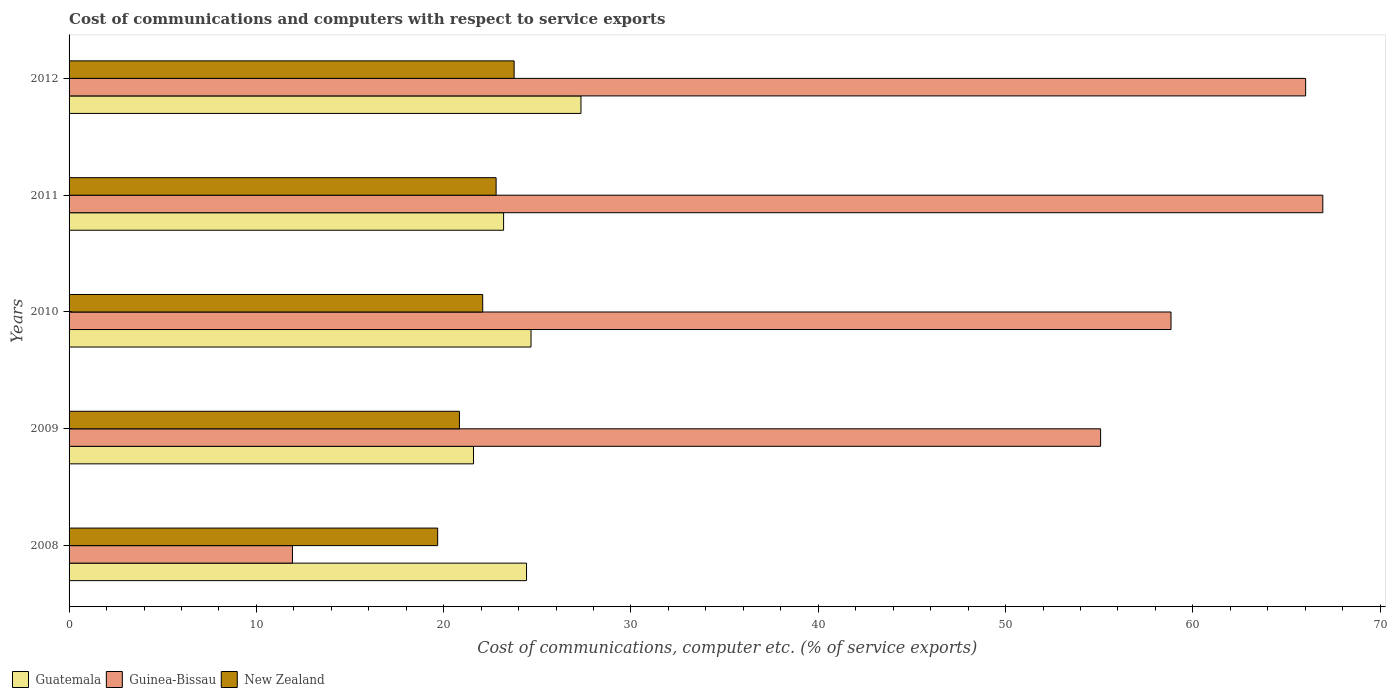Are the number of bars per tick equal to the number of legend labels?
Ensure brevity in your answer.  Yes. Are the number of bars on each tick of the Y-axis equal?
Provide a short and direct response. Yes. In how many cases, is the number of bars for a given year not equal to the number of legend labels?
Your answer should be compact. 0. What is the cost of communications and computers in Guatemala in 2008?
Make the answer very short. 24.42. Across all years, what is the maximum cost of communications and computers in Guatemala?
Your answer should be very brief. 27.33. Across all years, what is the minimum cost of communications and computers in Guatemala?
Offer a terse response. 21.59. In which year was the cost of communications and computers in Guatemala maximum?
Provide a short and direct response. 2012. In which year was the cost of communications and computers in New Zealand minimum?
Provide a short and direct response. 2008. What is the total cost of communications and computers in Guinea-Bissau in the graph?
Your answer should be very brief. 258.78. What is the difference between the cost of communications and computers in New Zealand in 2011 and that in 2012?
Your answer should be compact. -0.96. What is the difference between the cost of communications and computers in Guinea-Bissau in 2009 and the cost of communications and computers in Guatemala in 2008?
Your answer should be very brief. 30.65. What is the average cost of communications and computers in Guatemala per year?
Your answer should be compact. 24.24. In the year 2009, what is the difference between the cost of communications and computers in Guinea-Bissau and cost of communications and computers in New Zealand?
Your response must be concise. 34.23. What is the ratio of the cost of communications and computers in Guatemala in 2009 to that in 2011?
Provide a short and direct response. 0.93. Is the cost of communications and computers in New Zealand in 2009 less than that in 2010?
Your answer should be very brief. Yes. What is the difference between the highest and the second highest cost of communications and computers in Guinea-Bissau?
Your response must be concise. 0.92. What is the difference between the highest and the lowest cost of communications and computers in New Zealand?
Provide a succinct answer. 4.08. In how many years, is the cost of communications and computers in Guatemala greater than the average cost of communications and computers in Guatemala taken over all years?
Provide a succinct answer. 3. Is the sum of the cost of communications and computers in Guinea-Bissau in 2010 and 2012 greater than the maximum cost of communications and computers in New Zealand across all years?
Provide a short and direct response. Yes. What does the 1st bar from the top in 2010 represents?
Provide a succinct answer. New Zealand. What does the 1st bar from the bottom in 2010 represents?
Make the answer very short. Guatemala. How many bars are there?
Make the answer very short. 15. What is the difference between two consecutive major ticks on the X-axis?
Offer a very short reply. 10. What is the title of the graph?
Keep it short and to the point. Cost of communications and computers with respect to service exports. Does "Isle of Man" appear as one of the legend labels in the graph?
Ensure brevity in your answer.  No. What is the label or title of the X-axis?
Ensure brevity in your answer.  Cost of communications, computer etc. (% of service exports). What is the Cost of communications, computer etc. (% of service exports) in Guatemala in 2008?
Provide a succinct answer. 24.42. What is the Cost of communications, computer etc. (% of service exports) in Guinea-Bissau in 2008?
Your response must be concise. 11.93. What is the Cost of communications, computer etc. (% of service exports) of New Zealand in 2008?
Your answer should be very brief. 19.68. What is the Cost of communications, computer etc. (% of service exports) of Guatemala in 2009?
Ensure brevity in your answer.  21.59. What is the Cost of communications, computer etc. (% of service exports) in Guinea-Bissau in 2009?
Your answer should be very brief. 55.07. What is the Cost of communications, computer etc. (% of service exports) of New Zealand in 2009?
Your answer should be compact. 20.84. What is the Cost of communications, computer etc. (% of service exports) in Guatemala in 2010?
Offer a very short reply. 24.66. What is the Cost of communications, computer etc. (% of service exports) of Guinea-Bissau in 2010?
Keep it short and to the point. 58.83. What is the Cost of communications, computer etc. (% of service exports) of New Zealand in 2010?
Your response must be concise. 22.08. What is the Cost of communications, computer etc. (% of service exports) in Guatemala in 2011?
Offer a terse response. 23.2. What is the Cost of communications, computer etc. (% of service exports) of Guinea-Bissau in 2011?
Offer a terse response. 66.94. What is the Cost of communications, computer etc. (% of service exports) of New Zealand in 2011?
Give a very brief answer. 22.8. What is the Cost of communications, computer etc. (% of service exports) of Guatemala in 2012?
Keep it short and to the point. 27.33. What is the Cost of communications, computer etc. (% of service exports) of Guinea-Bissau in 2012?
Offer a very short reply. 66.02. What is the Cost of communications, computer etc. (% of service exports) of New Zealand in 2012?
Give a very brief answer. 23.76. Across all years, what is the maximum Cost of communications, computer etc. (% of service exports) in Guatemala?
Your response must be concise. 27.33. Across all years, what is the maximum Cost of communications, computer etc. (% of service exports) of Guinea-Bissau?
Your answer should be very brief. 66.94. Across all years, what is the maximum Cost of communications, computer etc. (% of service exports) in New Zealand?
Offer a very short reply. 23.76. Across all years, what is the minimum Cost of communications, computer etc. (% of service exports) of Guatemala?
Your answer should be compact. 21.59. Across all years, what is the minimum Cost of communications, computer etc. (% of service exports) in Guinea-Bissau?
Your response must be concise. 11.93. Across all years, what is the minimum Cost of communications, computer etc. (% of service exports) in New Zealand?
Your response must be concise. 19.68. What is the total Cost of communications, computer etc. (% of service exports) in Guatemala in the graph?
Your answer should be very brief. 121.21. What is the total Cost of communications, computer etc. (% of service exports) in Guinea-Bissau in the graph?
Your answer should be very brief. 258.78. What is the total Cost of communications, computer etc. (% of service exports) in New Zealand in the graph?
Give a very brief answer. 109.16. What is the difference between the Cost of communications, computer etc. (% of service exports) of Guatemala in 2008 and that in 2009?
Offer a very short reply. 2.83. What is the difference between the Cost of communications, computer etc. (% of service exports) of Guinea-Bissau in 2008 and that in 2009?
Provide a short and direct response. -43.15. What is the difference between the Cost of communications, computer etc. (% of service exports) of New Zealand in 2008 and that in 2009?
Your answer should be compact. -1.16. What is the difference between the Cost of communications, computer etc. (% of service exports) in Guatemala in 2008 and that in 2010?
Provide a short and direct response. -0.24. What is the difference between the Cost of communications, computer etc. (% of service exports) in Guinea-Bissau in 2008 and that in 2010?
Your response must be concise. -46.91. What is the difference between the Cost of communications, computer etc. (% of service exports) in New Zealand in 2008 and that in 2010?
Your answer should be compact. -2.4. What is the difference between the Cost of communications, computer etc. (% of service exports) of Guatemala in 2008 and that in 2011?
Keep it short and to the point. 1.22. What is the difference between the Cost of communications, computer etc. (% of service exports) in Guinea-Bissau in 2008 and that in 2011?
Provide a short and direct response. -55.01. What is the difference between the Cost of communications, computer etc. (% of service exports) in New Zealand in 2008 and that in 2011?
Ensure brevity in your answer.  -3.12. What is the difference between the Cost of communications, computer etc. (% of service exports) in Guatemala in 2008 and that in 2012?
Offer a very short reply. -2.91. What is the difference between the Cost of communications, computer etc. (% of service exports) in Guinea-Bissau in 2008 and that in 2012?
Make the answer very short. -54.09. What is the difference between the Cost of communications, computer etc. (% of service exports) of New Zealand in 2008 and that in 2012?
Ensure brevity in your answer.  -4.08. What is the difference between the Cost of communications, computer etc. (% of service exports) in Guatemala in 2009 and that in 2010?
Give a very brief answer. -3.07. What is the difference between the Cost of communications, computer etc. (% of service exports) in Guinea-Bissau in 2009 and that in 2010?
Your answer should be very brief. -3.76. What is the difference between the Cost of communications, computer etc. (% of service exports) in New Zealand in 2009 and that in 2010?
Provide a succinct answer. -1.24. What is the difference between the Cost of communications, computer etc. (% of service exports) in Guatemala in 2009 and that in 2011?
Your answer should be very brief. -1.61. What is the difference between the Cost of communications, computer etc. (% of service exports) of Guinea-Bissau in 2009 and that in 2011?
Ensure brevity in your answer.  -11.86. What is the difference between the Cost of communications, computer etc. (% of service exports) of New Zealand in 2009 and that in 2011?
Provide a succinct answer. -1.96. What is the difference between the Cost of communications, computer etc. (% of service exports) in Guatemala in 2009 and that in 2012?
Your answer should be compact. -5.74. What is the difference between the Cost of communications, computer etc. (% of service exports) in Guinea-Bissau in 2009 and that in 2012?
Keep it short and to the point. -10.95. What is the difference between the Cost of communications, computer etc. (% of service exports) of New Zealand in 2009 and that in 2012?
Give a very brief answer. -2.92. What is the difference between the Cost of communications, computer etc. (% of service exports) of Guatemala in 2010 and that in 2011?
Offer a very short reply. 1.47. What is the difference between the Cost of communications, computer etc. (% of service exports) of Guinea-Bissau in 2010 and that in 2011?
Your answer should be very brief. -8.1. What is the difference between the Cost of communications, computer etc. (% of service exports) of New Zealand in 2010 and that in 2011?
Ensure brevity in your answer.  -0.72. What is the difference between the Cost of communications, computer etc. (% of service exports) in Guatemala in 2010 and that in 2012?
Your answer should be compact. -2.67. What is the difference between the Cost of communications, computer etc. (% of service exports) of Guinea-Bissau in 2010 and that in 2012?
Give a very brief answer. -7.19. What is the difference between the Cost of communications, computer etc. (% of service exports) of New Zealand in 2010 and that in 2012?
Your answer should be compact. -1.68. What is the difference between the Cost of communications, computer etc. (% of service exports) of Guatemala in 2011 and that in 2012?
Your response must be concise. -4.13. What is the difference between the Cost of communications, computer etc. (% of service exports) in Guinea-Bissau in 2011 and that in 2012?
Provide a succinct answer. 0.92. What is the difference between the Cost of communications, computer etc. (% of service exports) of New Zealand in 2011 and that in 2012?
Provide a succinct answer. -0.96. What is the difference between the Cost of communications, computer etc. (% of service exports) in Guatemala in 2008 and the Cost of communications, computer etc. (% of service exports) in Guinea-Bissau in 2009?
Provide a short and direct response. -30.65. What is the difference between the Cost of communications, computer etc. (% of service exports) in Guatemala in 2008 and the Cost of communications, computer etc. (% of service exports) in New Zealand in 2009?
Your answer should be very brief. 3.58. What is the difference between the Cost of communications, computer etc. (% of service exports) in Guinea-Bissau in 2008 and the Cost of communications, computer etc. (% of service exports) in New Zealand in 2009?
Give a very brief answer. -8.91. What is the difference between the Cost of communications, computer etc. (% of service exports) in Guatemala in 2008 and the Cost of communications, computer etc. (% of service exports) in Guinea-Bissau in 2010?
Your answer should be very brief. -34.41. What is the difference between the Cost of communications, computer etc. (% of service exports) of Guatemala in 2008 and the Cost of communications, computer etc. (% of service exports) of New Zealand in 2010?
Offer a very short reply. 2.34. What is the difference between the Cost of communications, computer etc. (% of service exports) in Guinea-Bissau in 2008 and the Cost of communications, computer etc. (% of service exports) in New Zealand in 2010?
Your answer should be compact. -10.16. What is the difference between the Cost of communications, computer etc. (% of service exports) in Guatemala in 2008 and the Cost of communications, computer etc. (% of service exports) in Guinea-Bissau in 2011?
Your response must be concise. -42.51. What is the difference between the Cost of communications, computer etc. (% of service exports) in Guatemala in 2008 and the Cost of communications, computer etc. (% of service exports) in New Zealand in 2011?
Provide a succinct answer. 1.62. What is the difference between the Cost of communications, computer etc. (% of service exports) of Guinea-Bissau in 2008 and the Cost of communications, computer etc. (% of service exports) of New Zealand in 2011?
Your answer should be very brief. -10.87. What is the difference between the Cost of communications, computer etc. (% of service exports) in Guatemala in 2008 and the Cost of communications, computer etc. (% of service exports) in Guinea-Bissau in 2012?
Ensure brevity in your answer.  -41.6. What is the difference between the Cost of communications, computer etc. (% of service exports) of Guatemala in 2008 and the Cost of communications, computer etc. (% of service exports) of New Zealand in 2012?
Provide a short and direct response. 0.66. What is the difference between the Cost of communications, computer etc. (% of service exports) of Guinea-Bissau in 2008 and the Cost of communications, computer etc. (% of service exports) of New Zealand in 2012?
Your answer should be compact. -11.84. What is the difference between the Cost of communications, computer etc. (% of service exports) in Guatemala in 2009 and the Cost of communications, computer etc. (% of service exports) in Guinea-Bissau in 2010?
Give a very brief answer. -37.24. What is the difference between the Cost of communications, computer etc. (% of service exports) in Guatemala in 2009 and the Cost of communications, computer etc. (% of service exports) in New Zealand in 2010?
Offer a very short reply. -0.49. What is the difference between the Cost of communications, computer etc. (% of service exports) in Guinea-Bissau in 2009 and the Cost of communications, computer etc. (% of service exports) in New Zealand in 2010?
Your answer should be very brief. 32.99. What is the difference between the Cost of communications, computer etc. (% of service exports) in Guatemala in 2009 and the Cost of communications, computer etc. (% of service exports) in Guinea-Bissau in 2011?
Keep it short and to the point. -45.34. What is the difference between the Cost of communications, computer etc. (% of service exports) of Guatemala in 2009 and the Cost of communications, computer etc. (% of service exports) of New Zealand in 2011?
Ensure brevity in your answer.  -1.21. What is the difference between the Cost of communications, computer etc. (% of service exports) of Guinea-Bissau in 2009 and the Cost of communications, computer etc. (% of service exports) of New Zealand in 2011?
Provide a short and direct response. 32.27. What is the difference between the Cost of communications, computer etc. (% of service exports) in Guatemala in 2009 and the Cost of communications, computer etc. (% of service exports) in Guinea-Bissau in 2012?
Offer a terse response. -44.43. What is the difference between the Cost of communications, computer etc. (% of service exports) in Guatemala in 2009 and the Cost of communications, computer etc. (% of service exports) in New Zealand in 2012?
Provide a short and direct response. -2.17. What is the difference between the Cost of communications, computer etc. (% of service exports) of Guinea-Bissau in 2009 and the Cost of communications, computer etc. (% of service exports) of New Zealand in 2012?
Make the answer very short. 31.31. What is the difference between the Cost of communications, computer etc. (% of service exports) in Guatemala in 2010 and the Cost of communications, computer etc. (% of service exports) in Guinea-Bissau in 2011?
Make the answer very short. -42.27. What is the difference between the Cost of communications, computer etc. (% of service exports) in Guatemala in 2010 and the Cost of communications, computer etc. (% of service exports) in New Zealand in 2011?
Offer a very short reply. 1.86. What is the difference between the Cost of communications, computer etc. (% of service exports) in Guinea-Bissau in 2010 and the Cost of communications, computer etc. (% of service exports) in New Zealand in 2011?
Your answer should be very brief. 36.03. What is the difference between the Cost of communications, computer etc. (% of service exports) of Guatemala in 2010 and the Cost of communications, computer etc. (% of service exports) of Guinea-Bissau in 2012?
Your answer should be compact. -41.35. What is the difference between the Cost of communications, computer etc. (% of service exports) of Guatemala in 2010 and the Cost of communications, computer etc. (% of service exports) of New Zealand in 2012?
Provide a succinct answer. 0.9. What is the difference between the Cost of communications, computer etc. (% of service exports) in Guinea-Bissau in 2010 and the Cost of communications, computer etc. (% of service exports) in New Zealand in 2012?
Offer a very short reply. 35.07. What is the difference between the Cost of communications, computer etc. (% of service exports) of Guatemala in 2011 and the Cost of communications, computer etc. (% of service exports) of Guinea-Bissau in 2012?
Your answer should be compact. -42.82. What is the difference between the Cost of communications, computer etc. (% of service exports) in Guatemala in 2011 and the Cost of communications, computer etc. (% of service exports) in New Zealand in 2012?
Provide a succinct answer. -0.56. What is the difference between the Cost of communications, computer etc. (% of service exports) of Guinea-Bissau in 2011 and the Cost of communications, computer etc. (% of service exports) of New Zealand in 2012?
Offer a terse response. 43.17. What is the average Cost of communications, computer etc. (% of service exports) of Guatemala per year?
Offer a terse response. 24.24. What is the average Cost of communications, computer etc. (% of service exports) in Guinea-Bissau per year?
Provide a succinct answer. 51.76. What is the average Cost of communications, computer etc. (% of service exports) of New Zealand per year?
Provide a short and direct response. 21.83. In the year 2008, what is the difference between the Cost of communications, computer etc. (% of service exports) of Guatemala and Cost of communications, computer etc. (% of service exports) of Guinea-Bissau?
Make the answer very short. 12.5. In the year 2008, what is the difference between the Cost of communications, computer etc. (% of service exports) of Guatemala and Cost of communications, computer etc. (% of service exports) of New Zealand?
Your response must be concise. 4.74. In the year 2008, what is the difference between the Cost of communications, computer etc. (% of service exports) of Guinea-Bissau and Cost of communications, computer etc. (% of service exports) of New Zealand?
Provide a succinct answer. -7.75. In the year 2009, what is the difference between the Cost of communications, computer etc. (% of service exports) of Guatemala and Cost of communications, computer etc. (% of service exports) of Guinea-Bissau?
Your answer should be compact. -33.48. In the year 2009, what is the difference between the Cost of communications, computer etc. (% of service exports) in Guatemala and Cost of communications, computer etc. (% of service exports) in New Zealand?
Give a very brief answer. 0.75. In the year 2009, what is the difference between the Cost of communications, computer etc. (% of service exports) of Guinea-Bissau and Cost of communications, computer etc. (% of service exports) of New Zealand?
Make the answer very short. 34.23. In the year 2010, what is the difference between the Cost of communications, computer etc. (% of service exports) of Guatemala and Cost of communications, computer etc. (% of service exports) of Guinea-Bissau?
Offer a very short reply. -34.17. In the year 2010, what is the difference between the Cost of communications, computer etc. (% of service exports) in Guatemala and Cost of communications, computer etc. (% of service exports) in New Zealand?
Give a very brief answer. 2.58. In the year 2010, what is the difference between the Cost of communications, computer etc. (% of service exports) of Guinea-Bissau and Cost of communications, computer etc. (% of service exports) of New Zealand?
Offer a very short reply. 36.75. In the year 2011, what is the difference between the Cost of communications, computer etc. (% of service exports) of Guatemala and Cost of communications, computer etc. (% of service exports) of Guinea-Bissau?
Offer a very short reply. -43.74. In the year 2011, what is the difference between the Cost of communications, computer etc. (% of service exports) of Guatemala and Cost of communications, computer etc. (% of service exports) of New Zealand?
Give a very brief answer. 0.4. In the year 2011, what is the difference between the Cost of communications, computer etc. (% of service exports) of Guinea-Bissau and Cost of communications, computer etc. (% of service exports) of New Zealand?
Ensure brevity in your answer.  44.14. In the year 2012, what is the difference between the Cost of communications, computer etc. (% of service exports) of Guatemala and Cost of communications, computer etc. (% of service exports) of Guinea-Bissau?
Offer a terse response. -38.69. In the year 2012, what is the difference between the Cost of communications, computer etc. (% of service exports) in Guatemala and Cost of communications, computer etc. (% of service exports) in New Zealand?
Your answer should be compact. 3.57. In the year 2012, what is the difference between the Cost of communications, computer etc. (% of service exports) of Guinea-Bissau and Cost of communications, computer etc. (% of service exports) of New Zealand?
Your answer should be very brief. 42.26. What is the ratio of the Cost of communications, computer etc. (% of service exports) in Guatemala in 2008 to that in 2009?
Offer a terse response. 1.13. What is the ratio of the Cost of communications, computer etc. (% of service exports) in Guinea-Bissau in 2008 to that in 2009?
Offer a very short reply. 0.22. What is the ratio of the Cost of communications, computer etc. (% of service exports) in New Zealand in 2008 to that in 2009?
Ensure brevity in your answer.  0.94. What is the ratio of the Cost of communications, computer etc. (% of service exports) of Guatemala in 2008 to that in 2010?
Provide a short and direct response. 0.99. What is the ratio of the Cost of communications, computer etc. (% of service exports) of Guinea-Bissau in 2008 to that in 2010?
Your answer should be compact. 0.2. What is the ratio of the Cost of communications, computer etc. (% of service exports) in New Zealand in 2008 to that in 2010?
Ensure brevity in your answer.  0.89. What is the ratio of the Cost of communications, computer etc. (% of service exports) in Guatemala in 2008 to that in 2011?
Make the answer very short. 1.05. What is the ratio of the Cost of communications, computer etc. (% of service exports) in Guinea-Bissau in 2008 to that in 2011?
Ensure brevity in your answer.  0.18. What is the ratio of the Cost of communications, computer etc. (% of service exports) of New Zealand in 2008 to that in 2011?
Keep it short and to the point. 0.86. What is the ratio of the Cost of communications, computer etc. (% of service exports) in Guatemala in 2008 to that in 2012?
Your answer should be compact. 0.89. What is the ratio of the Cost of communications, computer etc. (% of service exports) in Guinea-Bissau in 2008 to that in 2012?
Provide a succinct answer. 0.18. What is the ratio of the Cost of communications, computer etc. (% of service exports) in New Zealand in 2008 to that in 2012?
Your answer should be compact. 0.83. What is the ratio of the Cost of communications, computer etc. (% of service exports) in Guatemala in 2009 to that in 2010?
Your answer should be very brief. 0.88. What is the ratio of the Cost of communications, computer etc. (% of service exports) in Guinea-Bissau in 2009 to that in 2010?
Give a very brief answer. 0.94. What is the ratio of the Cost of communications, computer etc. (% of service exports) of New Zealand in 2009 to that in 2010?
Provide a succinct answer. 0.94. What is the ratio of the Cost of communications, computer etc. (% of service exports) in Guatemala in 2009 to that in 2011?
Provide a succinct answer. 0.93. What is the ratio of the Cost of communications, computer etc. (% of service exports) in Guinea-Bissau in 2009 to that in 2011?
Ensure brevity in your answer.  0.82. What is the ratio of the Cost of communications, computer etc. (% of service exports) of New Zealand in 2009 to that in 2011?
Offer a terse response. 0.91. What is the ratio of the Cost of communications, computer etc. (% of service exports) of Guatemala in 2009 to that in 2012?
Your answer should be very brief. 0.79. What is the ratio of the Cost of communications, computer etc. (% of service exports) of Guinea-Bissau in 2009 to that in 2012?
Your answer should be very brief. 0.83. What is the ratio of the Cost of communications, computer etc. (% of service exports) in New Zealand in 2009 to that in 2012?
Ensure brevity in your answer.  0.88. What is the ratio of the Cost of communications, computer etc. (% of service exports) of Guatemala in 2010 to that in 2011?
Keep it short and to the point. 1.06. What is the ratio of the Cost of communications, computer etc. (% of service exports) in Guinea-Bissau in 2010 to that in 2011?
Offer a very short reply. 0.88. What is the ratio of the Cost of communications, computer etc. (% of service exports) of New Zealand in 2010 to that in 2011?
Give a very brief answer. 0.97. What is the ratio of the Cost of communications, computer etc. (% of service exports) of Guatemala in 2010 to that in 2012?
Provide a short and direct response. 0.9. What is the ratio of the Cost of communications, computer etc. (% of service exports) of Guinea-Bissau in 2010 to that in 2012?
Provide a short and direct response. 0.89. What is the ratio of the Cost of communications, computer etc. (% of service exports) in New Zealand in 2010 to that in 2012?
Make the answer very short. 0.93. What is the ratio of the Cost of communications, computer etc. (% of service exports) of Guatemala in 2011 to that in 2012?
Give a very brief answer. 0.85. What is the ratio of the Cost of communications, computer etc. (% of service exports) of Guinea-Bissau in 2011 to that in 2012?
Keep it short and to the point. 1.01. What is the ratio of the Cost of communications, computer etc. (% of service exports) of New Zealand in 2011 to that in 2012?
Offer a terse response. 0.96. What is the difference between the highest and the second highest Cost of communications, computer etc. (% of service exports) of Guatemala?
Make the answer very short. 2.67. What is the difference between the highest and the second highest Cost of communications, computer etc. (% of service exports) in Guinea-Bissau?
Your answer should be very brief. 0.92. What is the difference between the highest and the second highest Cost of communications, computer etc. (% of service exports) of New Zealand?
Keep it short and to the point. 0.96. What is the difference between the highest and the lowest Cost of communications, computer etc. (% of service exports) in Guatemala?
Your answer should be very brief. 5.74. What is the difference between the highest and the lowest Cost of communications, computer etc. (% of service exports) in Guinea-Bissau?
Give a very brief answer. 55.01. What is the difference between the highest and the lowest Cost of communications, computer etc. (% of service exports) in New Zealand?
Your answer should be compact. 4.08. 